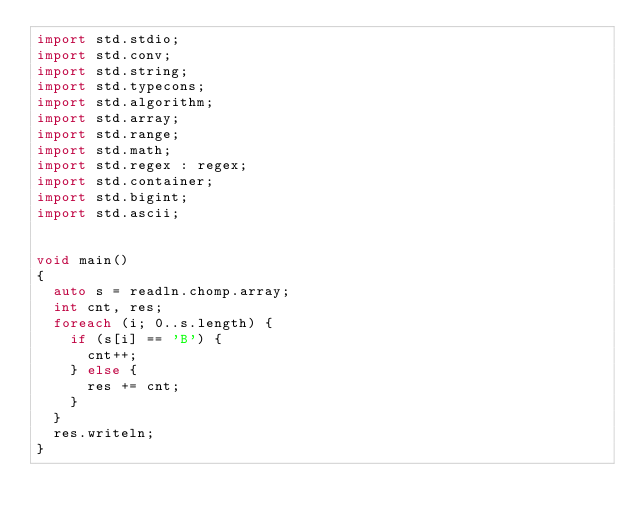Convert code to text. <code><loc_0><loc_0><loc_500><loc_500><_D_>import std.stdio;
import std.conv;
import std.string;
import std.typecons;
import std.algorithm;
import std.array;
import std.range;
import std.math;
import std.regex : regex;
import std.container;
import std.bigint;
import std.ascii;


void main()
{
  auto s = readln.chomp.array;
  int cnt, res;
  foreach (i; 0..s.length) {
    if (s[i] == 'B') {
      cnt++;
    } else {
      res += cnt;
    }
  }
  res.writeln;
}
</code> 